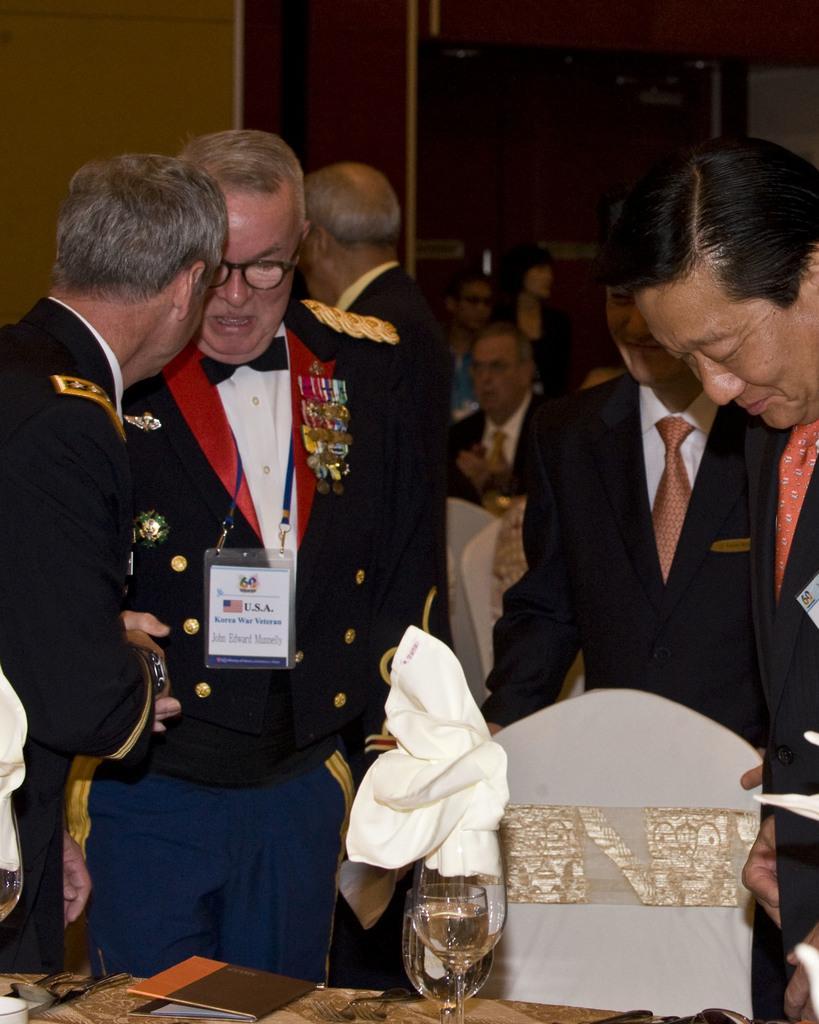Please provide a concise description of this image. In this image there are a group of people some of them are standing and some of them are sitting on chairs. In the foreground there is one table, on the table there are some books, glasses and one cloth. In the background there is a wall and some objects. 